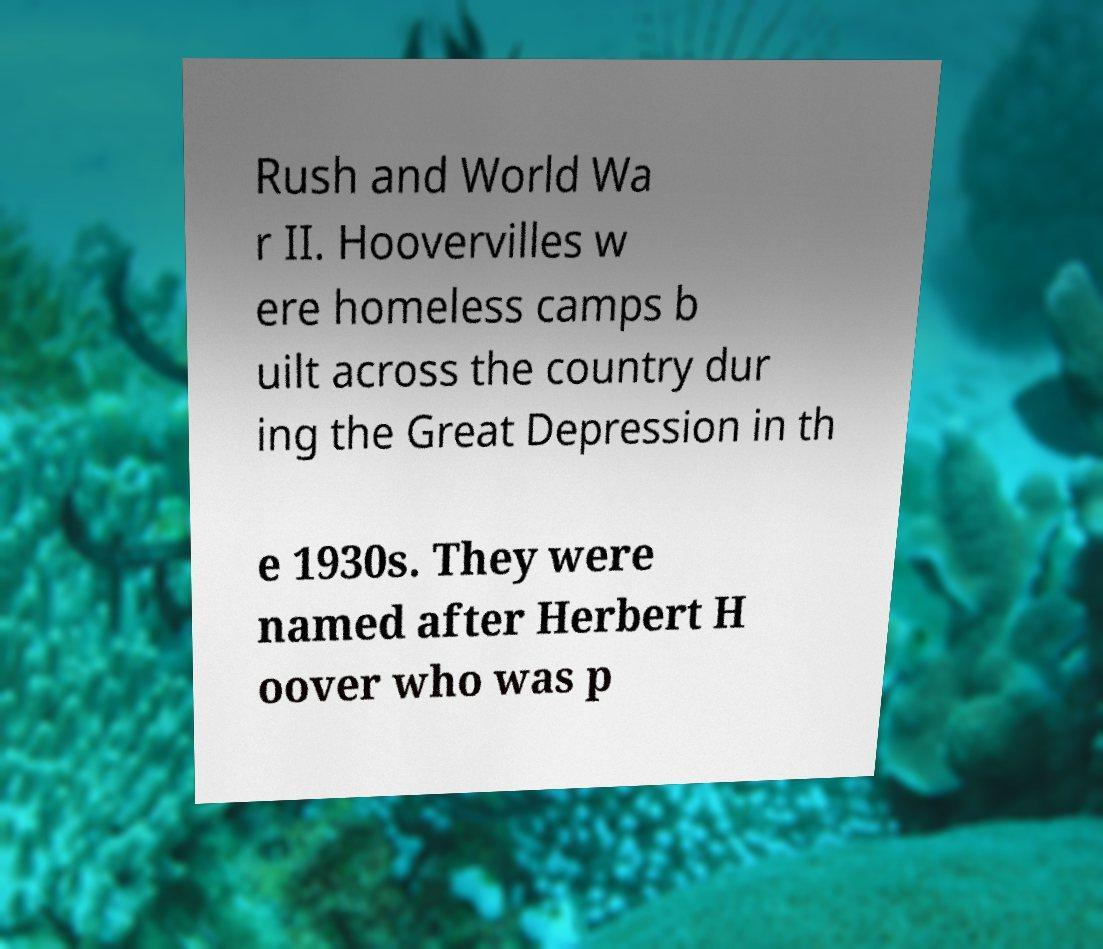I need the written content from this picture converted into text. Can you do that? Rush and World Wa r II. Hoovervilles w ere homeless camps b uilt across the country dur ing the Great Depression in th e 1930s. They were named after Herbert H oover who was p 